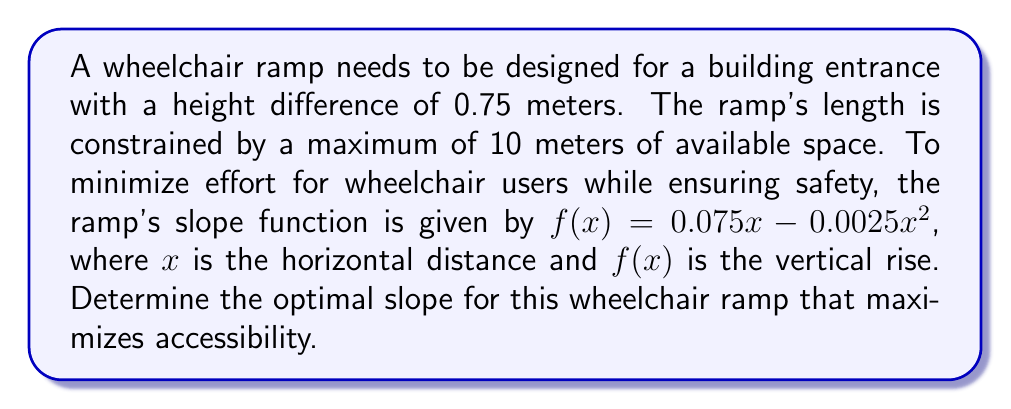Teach me how to tackle this problem. 1) The slope of the ramp at any point is given by the derivative of $f(x)$:

   $f'(x) = 0.075 - 0.005x$

2) To find the optimal slope, we need to find the maximum value of $f'(x)$ within the given constraints.

3) The constraint for $x$ is $0 \leq x \leq 10$ (since the maximum available space is 10 meters).

4) The maximum value of $f'(x)$ will occur at $x = 0$ (since the function is decreasing):

   $f'(0) = 0.075 - 0.005(0) = 0.075$

5) We need to verify if this slope allows the ramp to reach the required height of 0.75 meters:

   $f(10) = 0.075(10) - 0.0025(10)^2 = 0.75 - 0.25 = 0.5$ meters

6) This is less than the required 0.75 meters, so we need to use the entire 10 meters.

7) The actual slope at $x = 10$ is:

   $f'(10) = 0.075 - 0.005(10) = 0.025$

8) This slope of 0.025 or 1:40 is within typical accessibility guidelines (usually 1:12 to 1:20).
Answer: 0.025 or 1:40 